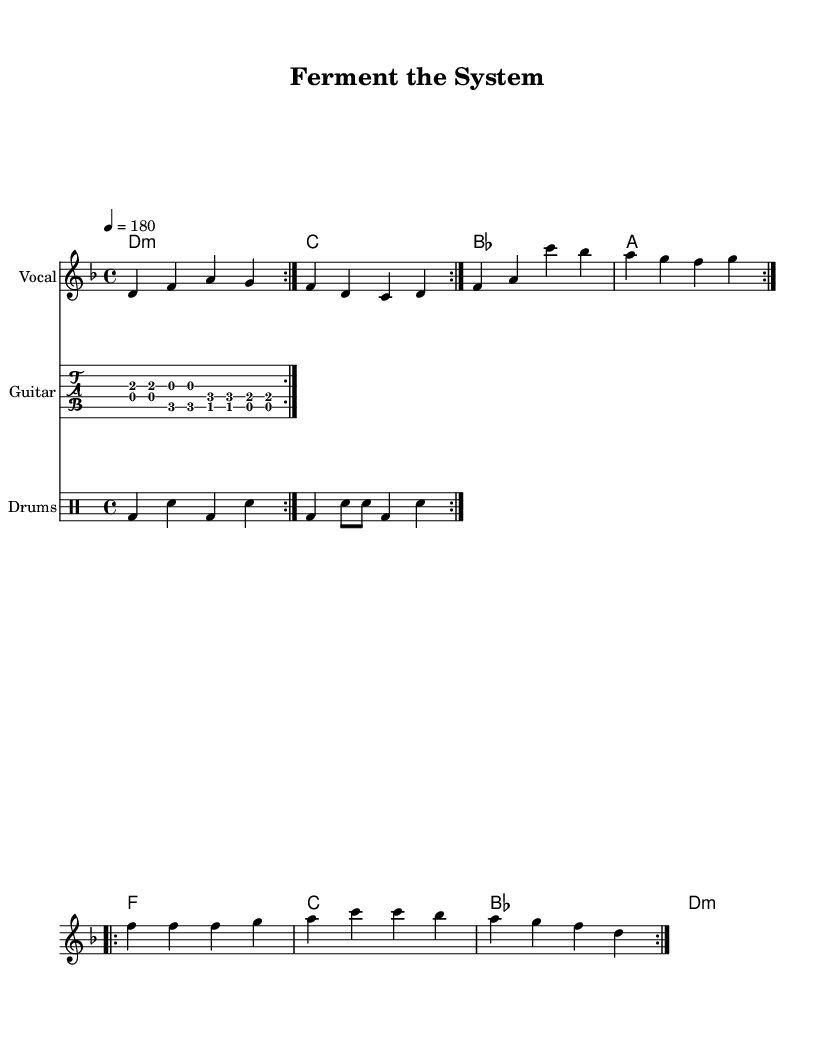What is the key signature of this music? The key signature is D minor, which has one flat (B flat).
Answer: D minor What is the time signature of this music? The time signature is 4/4, which indicates four beats per measure.
Answer: 4/4 What is the tempo marking for this piece? The tempo marking is 180 beats per minute, which sets the pace for the song.
Answer: 180 How many verses are there in the song? There are two repeated verses in the song as indicated by the repeated section in the lyrics.
Answer: Two What type of song structure is used in this piece? The structure follows a verse and chorus format, typical in punk music.
Answer: Verse and chorus How many bars are in the melody section that repeats? The melody section repeats for four bars per cycle indicated by the repeat volta markings.
Answer: Four What is the main theme of the lyrics in the song? The lyrics celebrate unconventional cooking techniques and experimental gastronomy.
Answer: Experimental gastronomy 